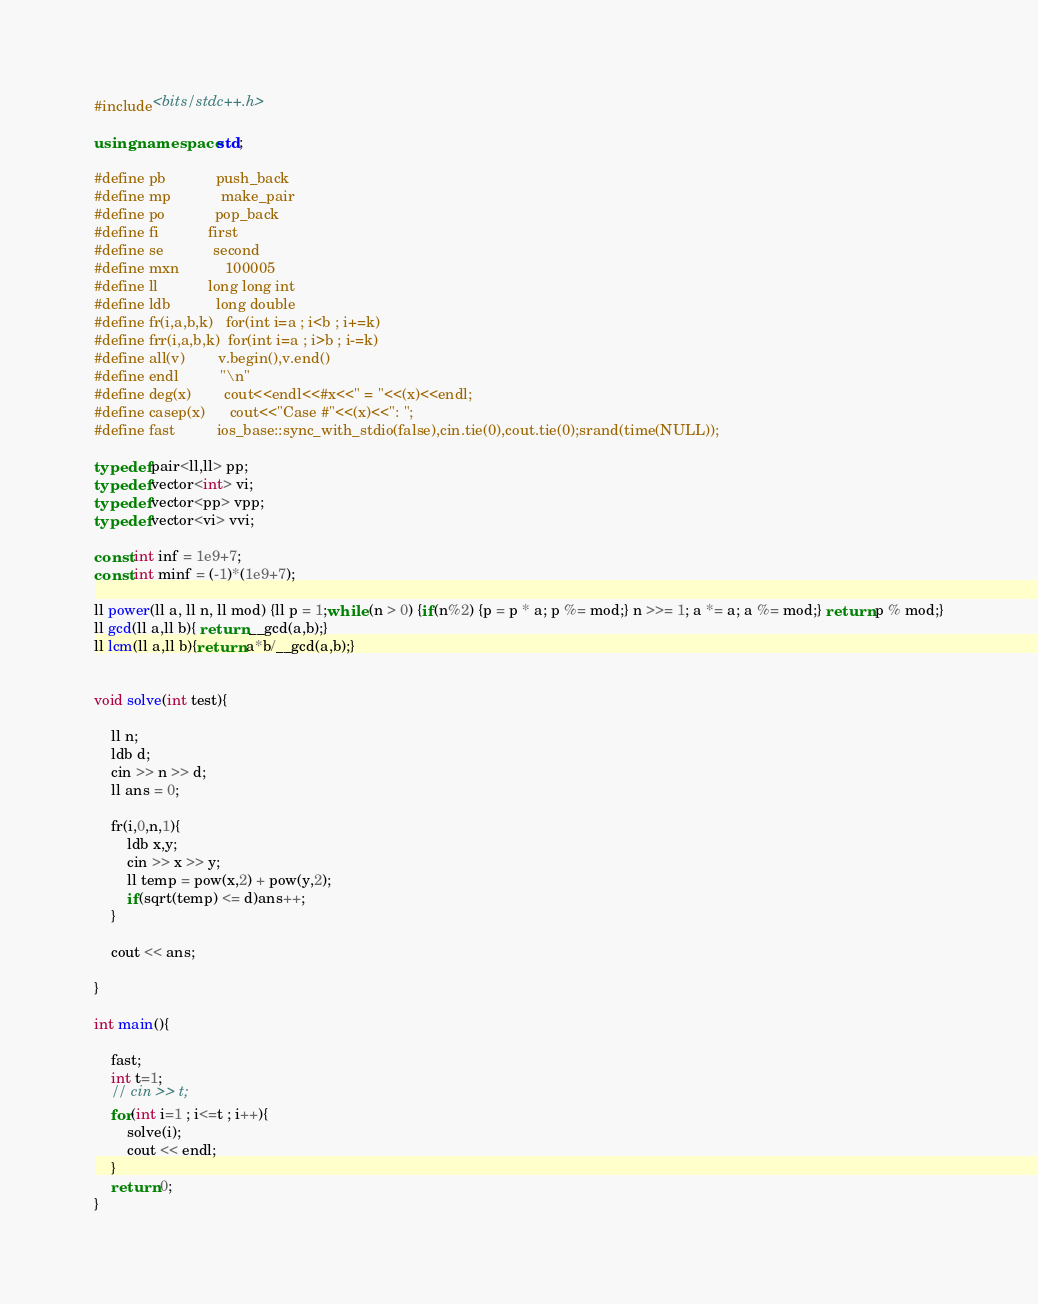Convert code to text. <code><loc_0><loc_0><loc_500><loc_500><_C++_>#include<bits/stdc++.h>

using namespace std;

#define pb            push_back
#define mp            make_pair
#define po            pop_back
#define fi            first
#define se            second
#define mxn           100005
#define ll            long long int
#define ldb           long double
#define fr(i,a,b,k)   for(int i=a ; i<b ; i+=k)
#define frr(i,a,b,k)  for(int i=a ; i>b ; i-=k)
#define all(v)        v.begin(),v.end()
#define endl          "\n"
#define deg(x)        cout<<endl<<#x<<" = "<<(x)<<endl;
#define casep(x)      cout<<"Case #"<<(x)<<": ";
#define fast          ios_base::sync_with_stdio(false),cin.tie(0),cout.tie(0);srand(time(NULL));

typedef pair<ll,ll> pp;
typedef vector<int> vi;
typedef vector<pp> vpp;
typedef vector<vi> vvi;

const int inf = 1e9+7;
const int minf = (-1)*(1e9+7);

ll power(ll a, ll n, ll mod) {ll p = 1;while (n > 0) {if(n%2) {p = p * a; p %= mod;} n >>= 1; a *= a; a %= mod;} return p % mod;}
ll gcd(ll a,ll b){ return __gcd(a,b);}
ll lcm(ll a,ll b){return a*b/__gcd(a,b);}


void solve(int test){

    ll n;
    ldb d;
    cin >> n >> d;
    ll ans = 0;

    fr(i,0,n,1){
        ldb x,y;
        cin >> x >> y;
        ll temp = pow(x,2) + pow(y,2);
        if(sqrt(temp) <= d)ans++;
    }

    cout << ans;

}

int main(){

    fast;
    int t=1;
    // cin >> t;
    for(int i=1 ; i<=t ; i++){
        solve(i);
        cout << endl;
    }
    return 0;
}
</code> 